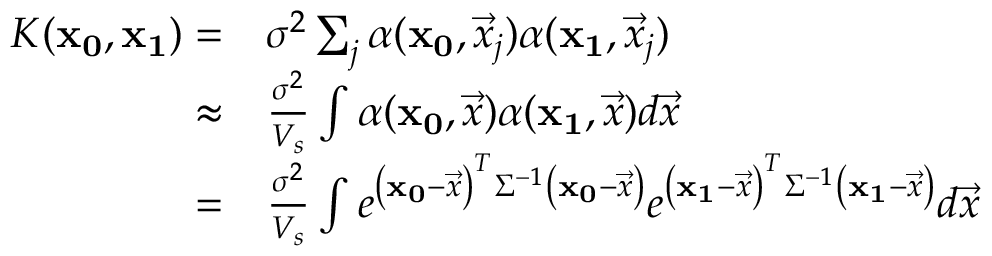Convert formula to latex. <formula><loc_0><loc_0><loc_500><loc_500>\begin{array} { r l } { K ( x _ { 0 } , x _ { 1 } ) = } & \sigma ^ { 2 } \sum _ { j } \alpha ( x _ { 0 } , \vec { x } _ { j } ) \alpha ( x _ { 1 } , \vec { x } _ { j } ) } \\ { \approx } & \frac { \sigma ^ { 2 } } { V _ { s } } \int \alpha ( x _ { 0 } , \vec { x } ) \alpha ( x _ { 1 } , \vec { x } ) d \vec { x } } \\ { = } & \frac { \sigma ^ { 2 } } { V _ { s } } \int e ^ { \left ( x _ { 0 } - \vec { x } \right ) ^ { T } \Sigma ^ { - 1 } \left ( x _ { 0 } - \vec { x } \right ) } e ^ { \left ( x _ { 1 } - \vec { x } \right ) ^ { T } \Sigma ^ { - 1 } \left ( x _ { 1 } - \vec { x } \right ) } d \vec { x } } \end{array}</formula> 